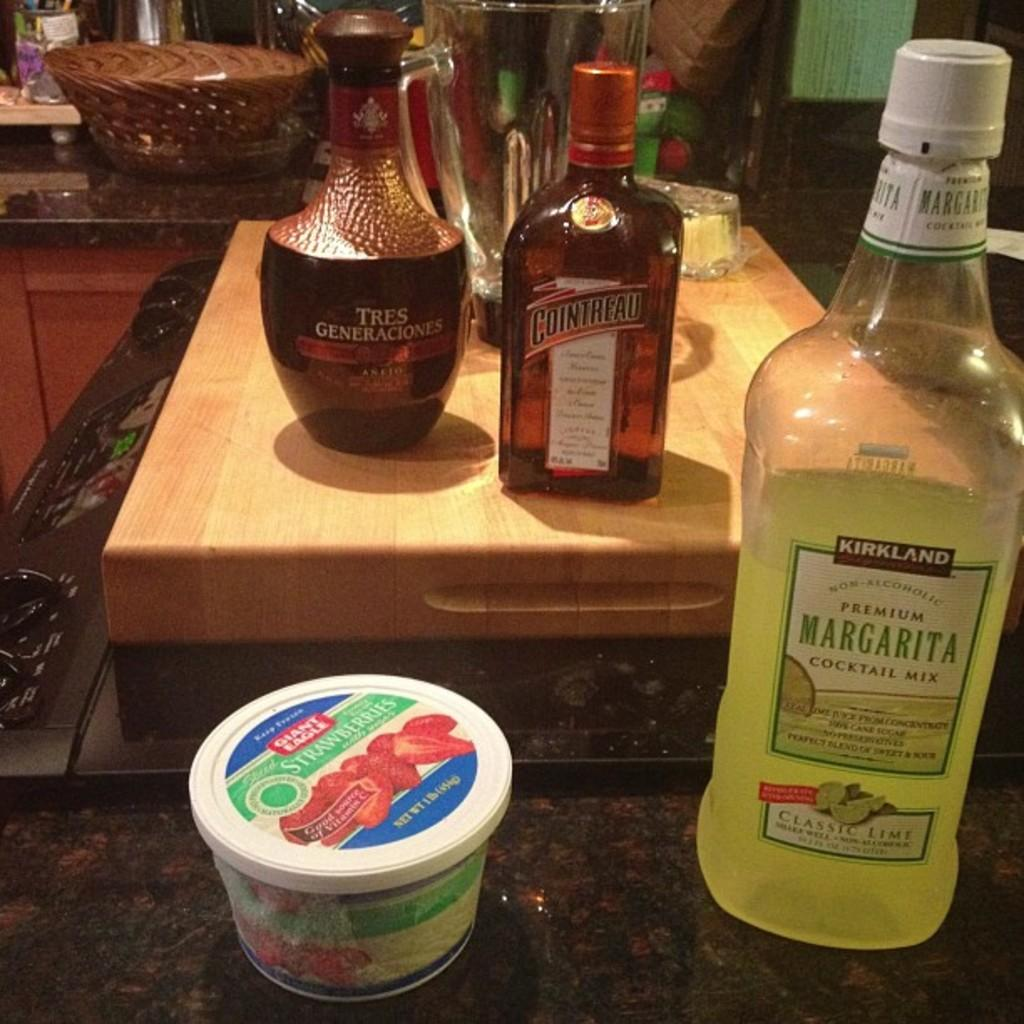<image>
Write a terse but informative summary of the picture. a bottle that has the word margarita on it 